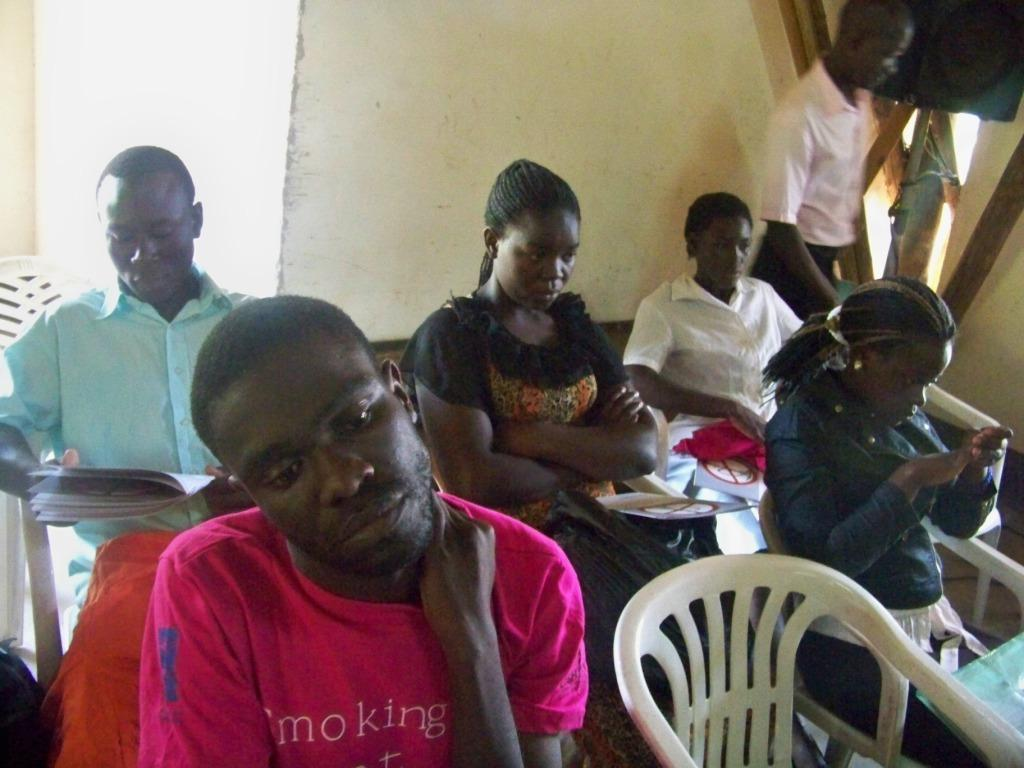What are the people in the image doing? The persons in the image are sitting on chairs. Is there anyone standing in the image? Yes, there is a person standing on the floor in the image. What can be seen in the background of the image? There is a wall visible in the image. Can you see any veins in the image? There are no visible veins in the image; it features people sitting on chairs and standing on the floor, as well as a wall in the background. 